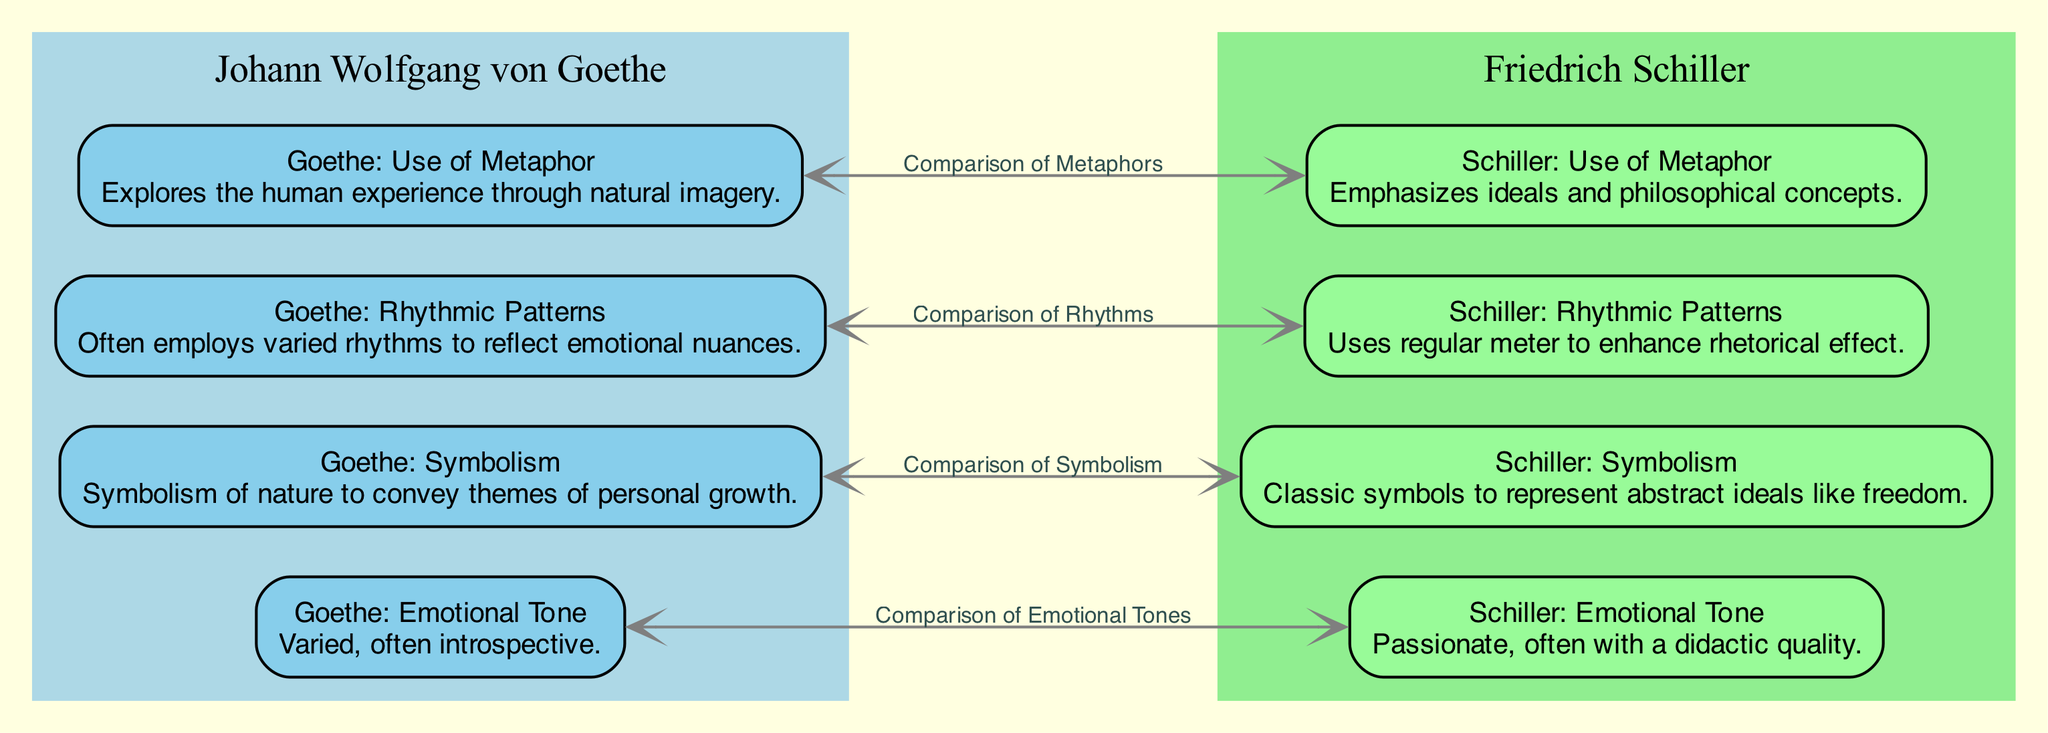What is the emotional tone of Goethe's poetry? The diagram specifically shows that Goethe's emotional tone is "Varied, often introspective," as indicated in the node labeled "Goethe: Emotional Tone."
Answer: Varied, often introspective How many nodes represent Schiller's poetic devices? The diagram shows four nodes specifically labeled for Schiller, indicating his use of metaphor, rhythmic patterns, symbolism, and emotional tone. Thus, counting these nodes gives the total.
Answer: 4 What type of symbolism does Goethe use? The corresponding node for Goethe in the diagram states that his symbolism involves "Symbolism of nature to convey themes of personal growth." This is a direct description from the diagram.
Answer: Symbolism of nature to convey themes of personal growth Which poet emphasizes ideals in their use of metaphor? Referring to the diagram, it is clear that the node titled "Schiller: Use of Metaphor" details his emphasis on "ideals and philosophical concepts," signifying that Schiller is the poet in question.
Answer: Schiller What is the comparison relationship between Goethe's and Schiller's rhythmic patterns? The diagram presents a direct edge labeled "Comparison of Rhythms" connecting the nodes for Goethe and Schiller, which indicates their rhythmic approaches are being compared. The rhythmic pattern for Schiller is presented as using "regular meter."
Answer: Comparison of Rhythms How does Goethe's use of metaphor differ from Schiller's? To answer this question, we refer to the descriptions in the nodes: Goethe's use of metaphor "Explores the human experience through natural imagery," while Schiller's emphasizes "ideals and philosophical concepts." The comparison between these two representations provides the differentiation.
Answer: Explores human experience vs. ideals and philosophical concepts What is the emotional tone used by Schiller? The diagram indicates in the node for Schiller's emotional tone that it's described as "Passionate, often with a didactic quality." This is clearly stated in the respective node.
Answer: Passionate, often with a didactic quality Which poetic device comparison does not involve emotional tone? The edges labeled in the diagram allow us to analyze the connections; both "Comparison of Metaphors" and "Comparison of Symbolism" do not involve emotional tone, while the edge labeled "Comparison of Emotional Tones" does. Thus, the answer focuses on the other comparisons.
Answer: Comparison of Metaphors, Comparison of Symbolism What rhythmic pattern does Goethe often employ? According to the node titled "Goethe: Rhythmic Patterns," it states that he "Often employs varied rhythms to reflect emotional nuances," giving a clear direct answer to this specific question.
Answer: Varied rhythms to reflect emotional nuances 